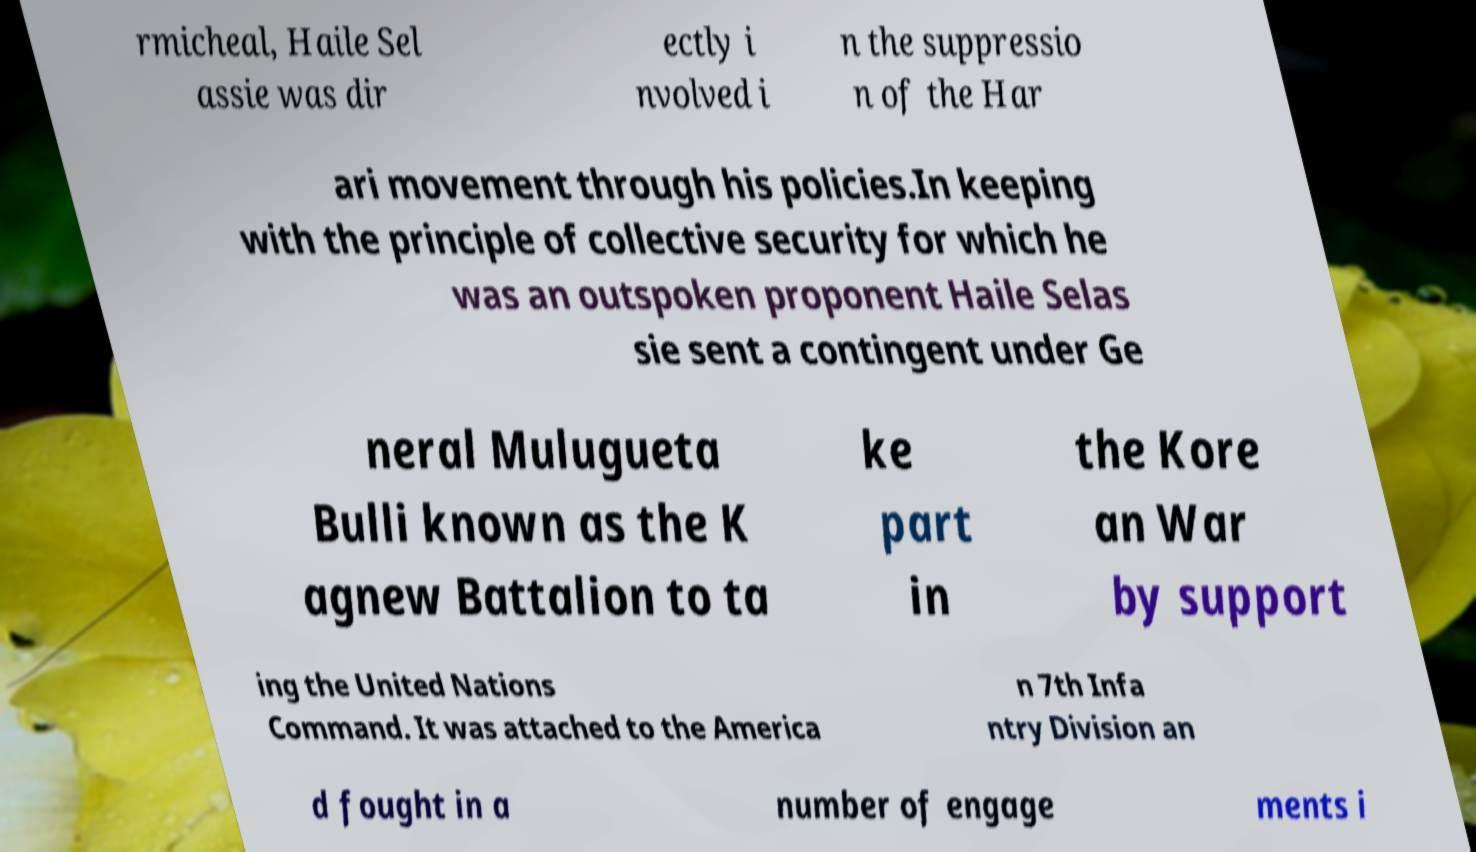What messages or text are displayed in this image? I need them in a readable, typed format. rmicheal, Haile Sel assie was dir ectly i nvolved i n the suppressio n of the Har ari movement through his policies.In keeping with the principle of collective security for which he was an outspoken proponent Haile Selas sie sent a contingent under Ge neral Mulugueta Bulli known as the K agnew Battalion to ta ke part in the Kore an War by support ing the United Nations Command. It was attached to the America n 7th Infa ntry Division an d fought in a number of engage ments i 